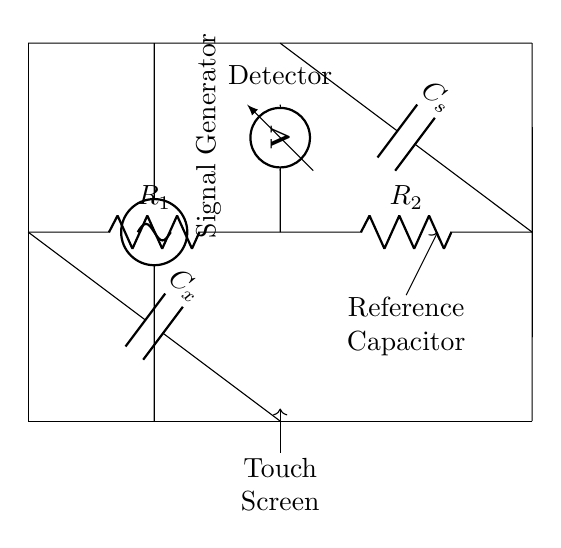What components are present in this circuit? The circuit includes two resistors, one capacitor (C_x), one reference capacitor (C_s), a signal generator, and a voltmeter.
Answer: Two resistors, two capacitors, a signal generator, a voltmeter What does R_1 and R_2 represent? R_1 and R_2 are the two resistors in the circuit used to balance the capacitance measurement during the operation of the bridge.
Answer: Two resistors How many capacitors are in this circuit? There are two capacitors in the circuit: C_x (the unknown capacitance) and C_s (the reference capacitance).
Answer: Two capacitors What is the function of the signal generator? The signal generator provides an alternating voltage signal to the circuit, which helps in measuring the capacitance of the touchscreen display.
Answer: Provides an alternating voltage signal Why is there a voltmeter in the circuit? The voltmeter measures the voltage difference across a part of the circuit, enabling the evaluation of the balance condition of the capacitance bridge.
Answer: To measure voltage difference What is the role of the reference capacitor C_s? The reference capacitor C_s is used to compare with the unknown capacitor C_x, allowing the determination of the unknown capacitance based on the balance of the bridge.
Answer: Compare with the unknown capacitor In what condition is the circuit balanced? The circuit is balanced when the voltage measured by the voltmeter is zero, indicating that the impedances are equal on both sides of the bridge.
Answer: When the voltmeter reads zero 